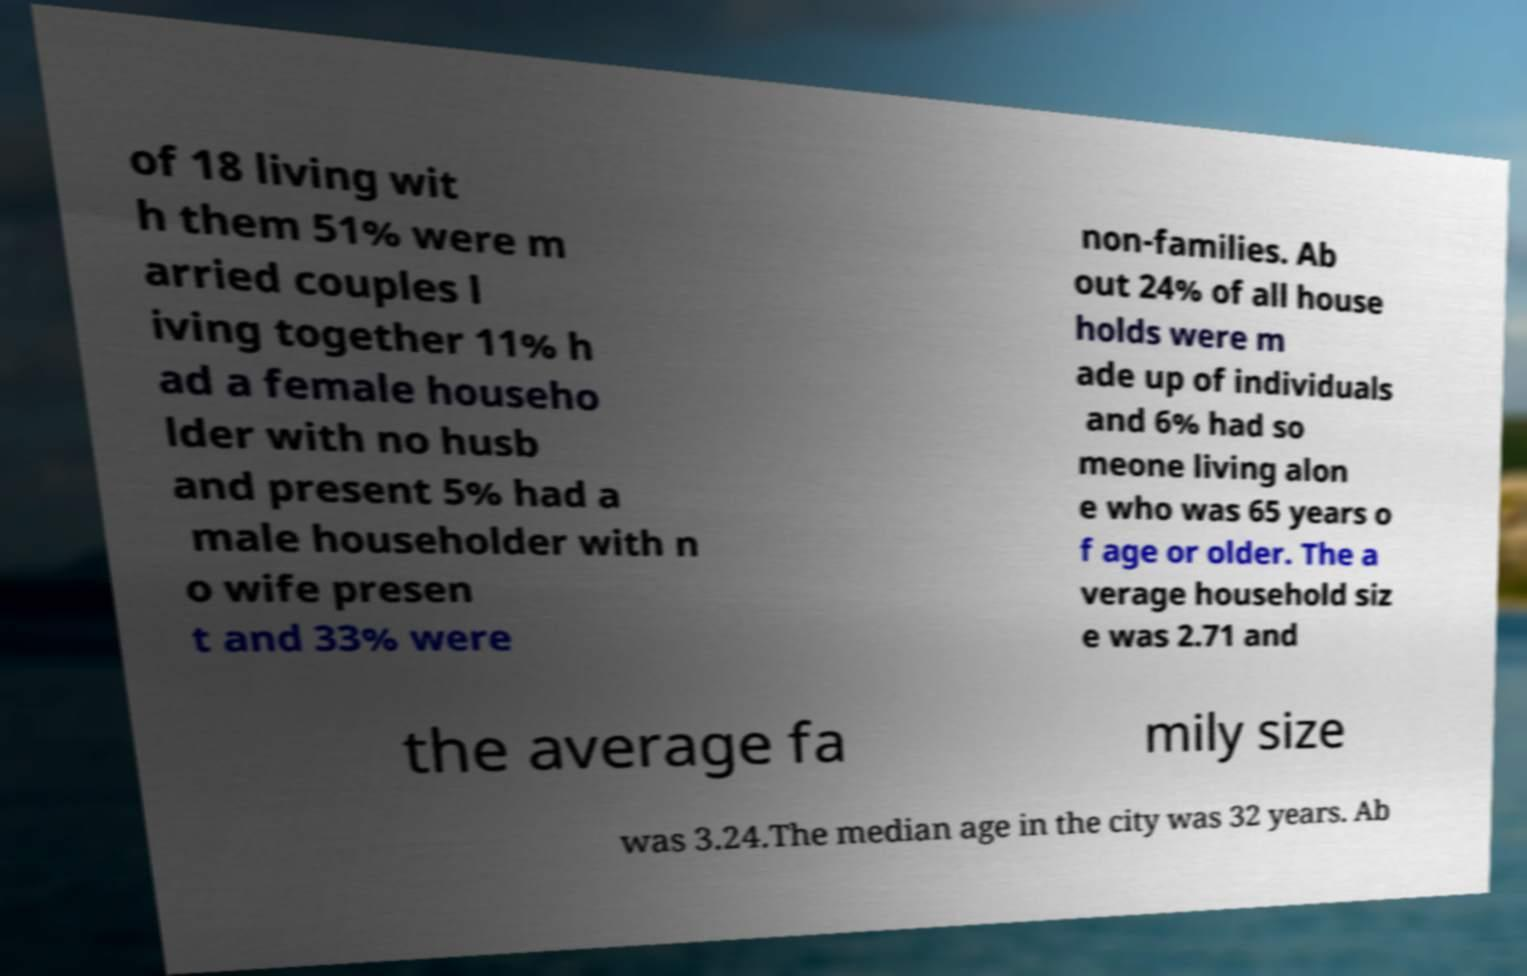Can you read and provide the text displayed in the image?This photo seems to have some interesting text. Can you extract and type it out for me? of 18 living wit h them 51% were m arried couples l iving together 11% h ad a female househo lder with no husb and present 5% had a male householder with n o wife presen t and 33% were non-families. Ab out 24% of all house holds were m ade up of individuals and 6% had so meone living alon e who was 65 years o f age or older. The a verage household siz e was 2.71 and the average fa mily size was 3.24.The median age in the city was 32 years. Ab 